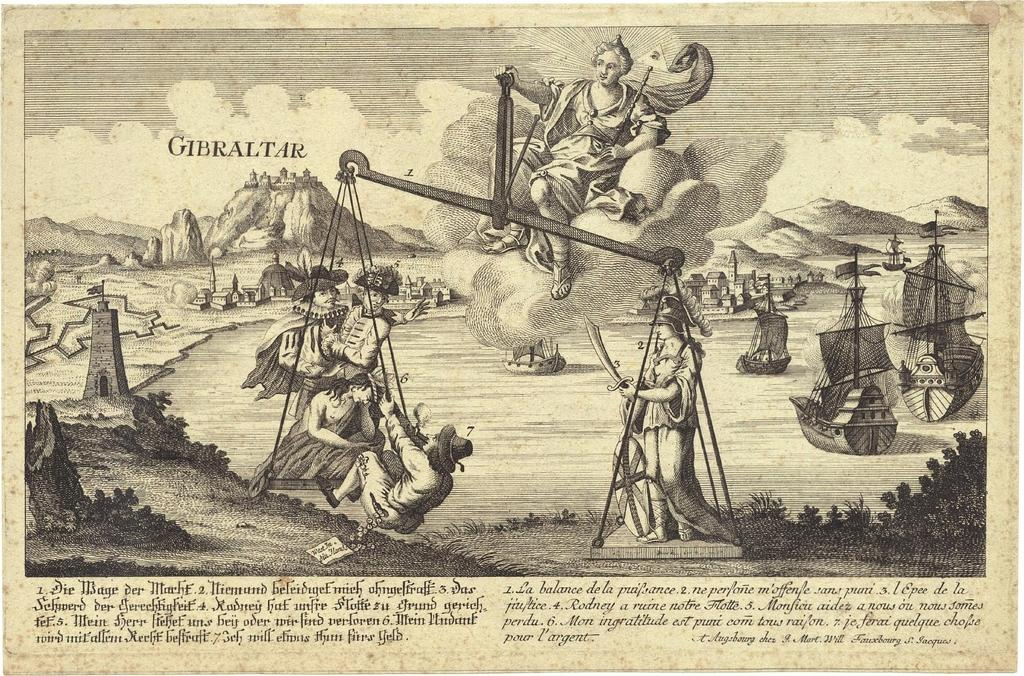What can be found at the bottom of the image? There is text at the bottom of the image. What is the girl in the image doing? The girl is balancing weights in the middle of the image. What type of landscape is visible in the background of the image? There are hills in the background of the image. What is visible at the top of the image? The sky is visible at the top of the image. Can you see a giraffe in the image? No, there is no giraffe present in the image. How many eggs are being carried by the girl in the image? There are no eggs visible in the image; the girl is balancing weights. 